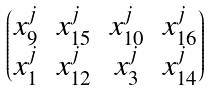<formula> <loc_0><loc_0><loc_500><loc_500>\begin{pmatrix} x _ { 9 } ^ { j } & x _ { 1 5 } ^ { j } & x _ { 1 0 } ^ { j } & x _ { 1 6 } ^ { j } \\ x _ { 1 } ^ { j } & x _ { 1 2 } ^ { j } & x _ { 3 } ^ { j } & x _ { 1 4 } ^ { j } \end{pmatrix}</formula> 